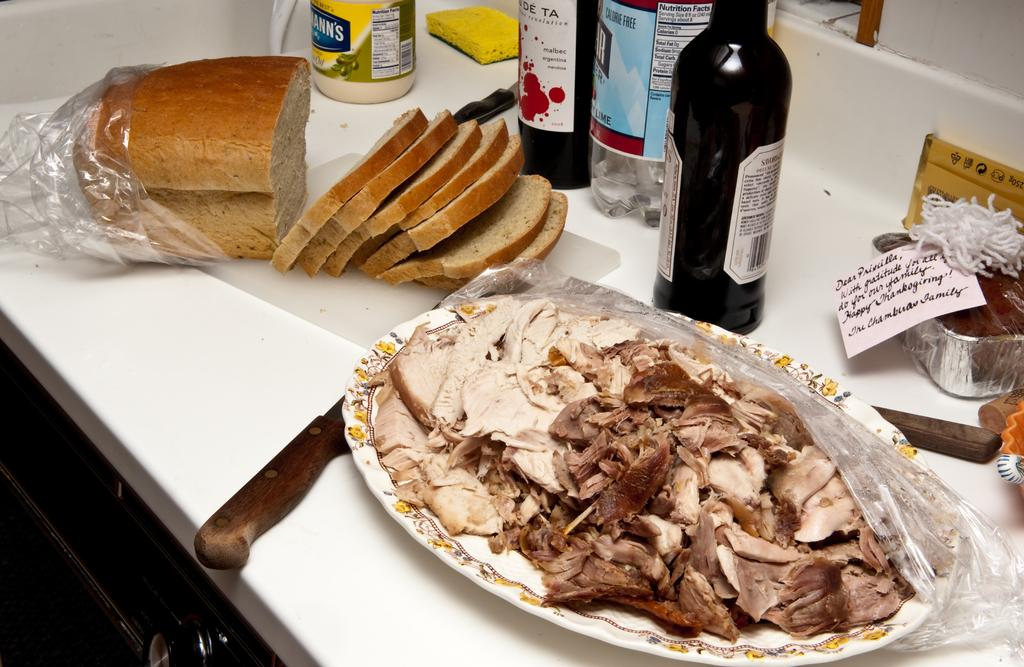What type of furniture is present in the image? There is a table in the image. What items can be seen on the table? There are bottles, knives, a cake, bread, and a plate of meat on the table. What is the background of the image? There is a wall in the background of the image. What type of watch is the person wearing in the image? There is no person wearing a watch in the image; it only features a table with various items on it and a wall in the background. 